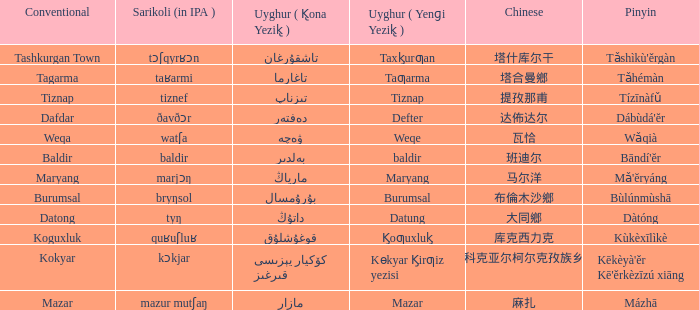Provide the customary designation for تاغارما. Tagarma. 